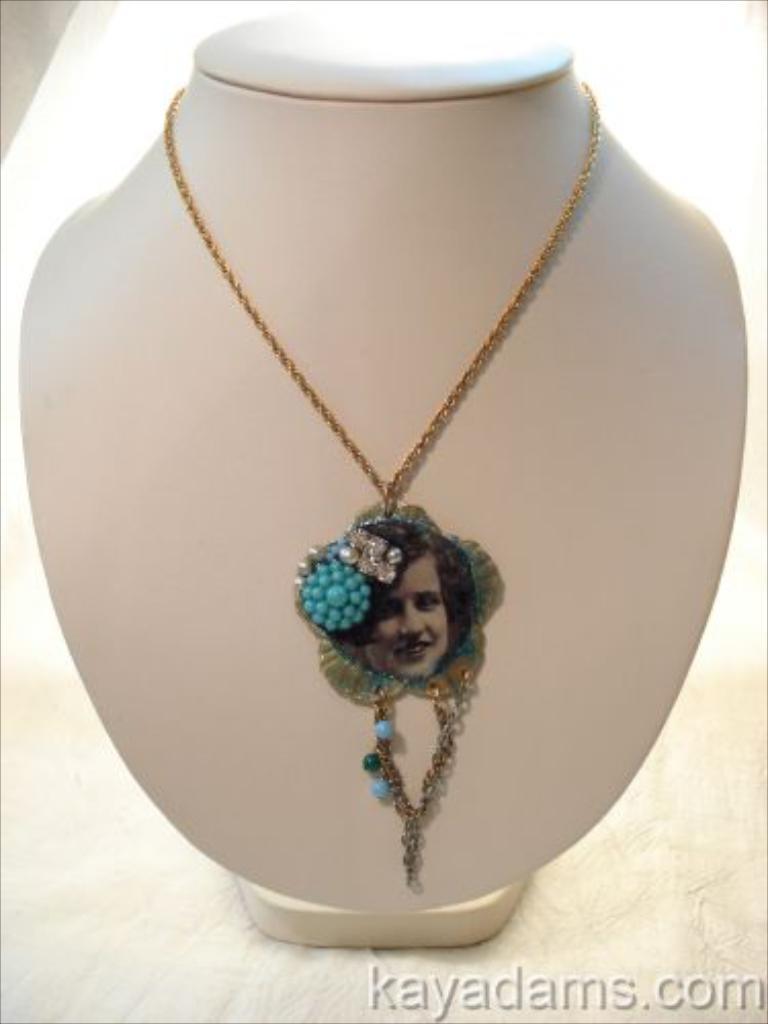Can you describe this image briefly? In this image there is a jewellery on the object which is white in colour with the image of the person in it and there is some text written on the image. 